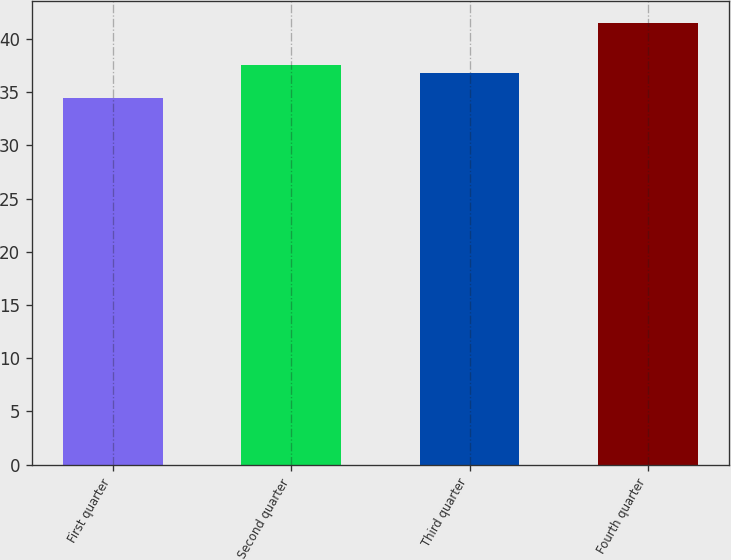Convert chart to OTSL. <chart><loc_0><loc_0><loc_500><loc_500><bar_chart><fcel>First quarter<fcel>Second quarter<fcel>Third quarter<fcel>Fourth quarter<nl><fcel>34.4<fcel>37.54<fcel>36.77<fcel>41.45<nl></chart> 